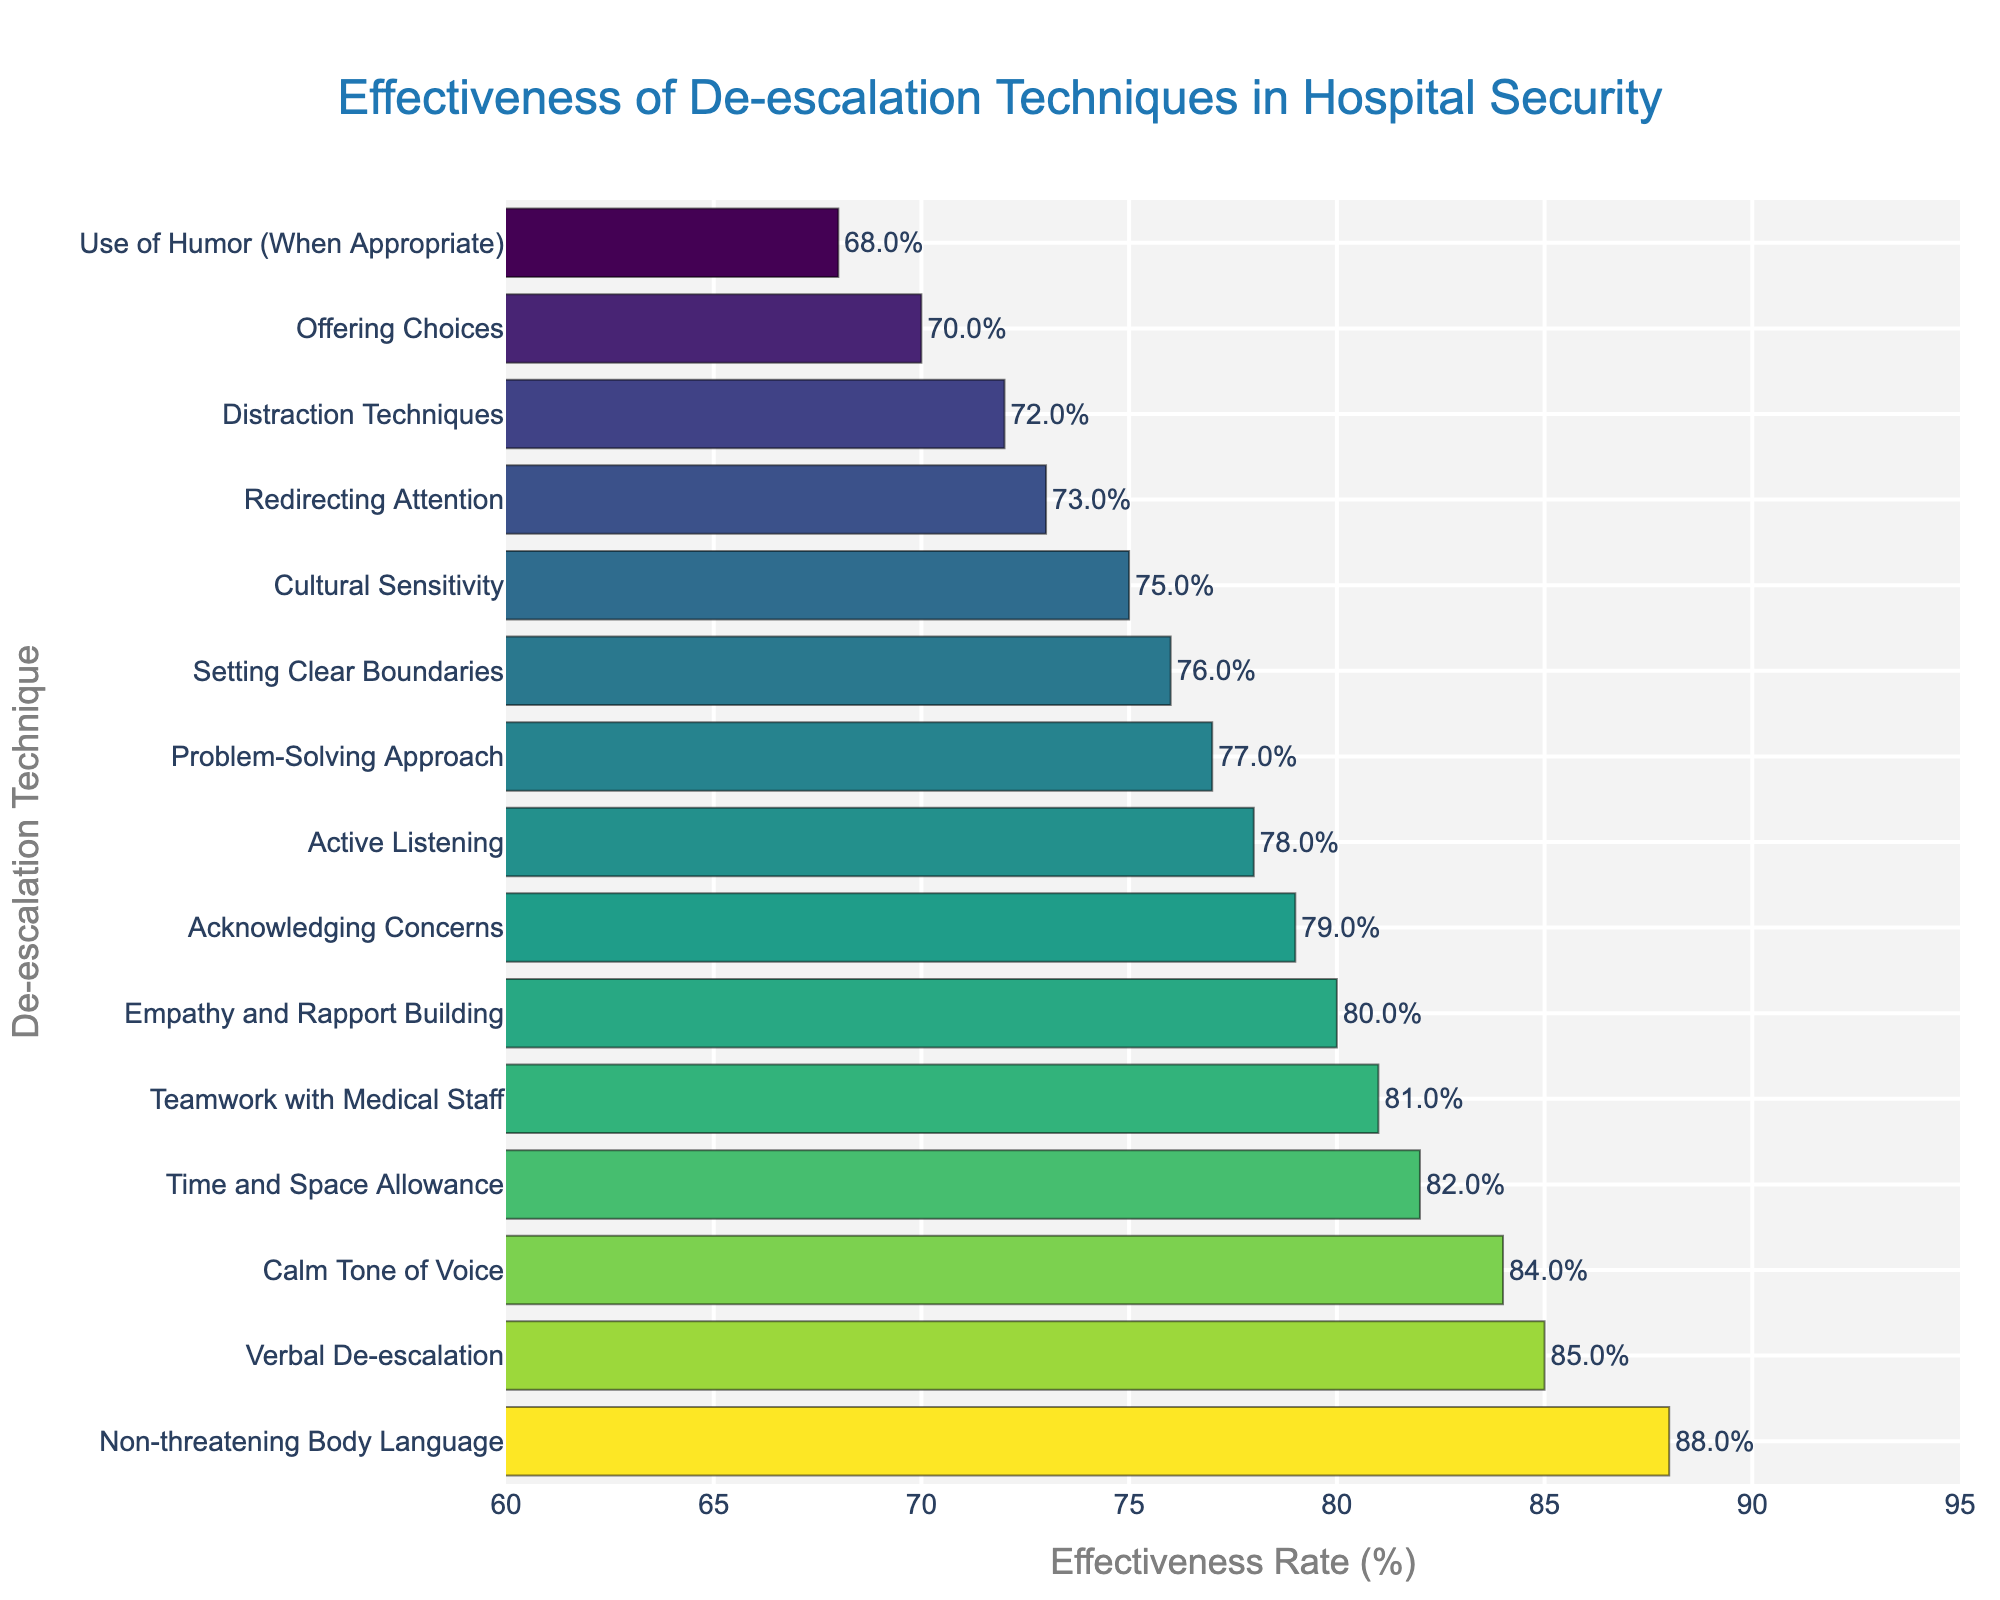What's the most effective de-escalation technique used by security staff? By observing the bars in the chart, the technique with the longest bar and highest effectiveness rate is the most effective.
Answer: Non-threatening Body Language Which technique has the lowest effectiveness rate? The technique with the shortest bar and lowest value is the least effective.
Answer: Use of Humor (When Appropriate) What is the combined effectiveness rate of 'Verbal De-escalation' and 'Calm Tone of Voice'? Summing the effectiveness rates of 'Verbal De-escalation' (85) and 'Calm Tone of Voice' (84) gives 85 + 84.
Answer: 169 How does 'Empathy and Rapport Building' compare to 'Setting Clear Boundaries' in terms of effectiveness? Comparing their effectiveness rates, 'Empathy and Rapport Building' has a rate of 80, while 'Setting Clear Boundaries' has a rate of 76, making the former more effective by 4%.
Answer: Empathy and Rapport Building is more effective by 4% Which three techniques have effectiveness rates closest to 80%? By closely examining the values, the techniques near 80% are 'Empathy and Rapport Building' (80%), 'Time and Space Allowance' (82%), and 'Acknowledging Concerns' (79%).
Answer: Empathy and Rapport Building, Time and Space Allowance, Acknowledging Concerns What is the average effectiveness rate of all the techniques? Summing all the effectiveness rates and dividing by the number of techniques, there are 15 techniques with a total effectiveness rate of 1188, hence the average is 1188/15.
Answer: 79.2% Which technique is more effective: 'Active Listening' or 'Problem-Solving Approach'? By comparing their effectiveness rates, 'Active Listening' has a rate of 78%, while 'Problem-Solving Approach' has a rate of 77%.
Answer: Active Listening What is the effectiveness rate range between the most and least effective techniques? The range is calculated by subtracting the rate of the least effective technique (68 for Use of Humor) from the most effective technique (88 for Non-threatening Body Language).
Answer: 20% How similar in effectiveness are 'Distraction Techniques' and 'Redirecting Attention'? Both techniques have close effectiveness rates, with 'Distraction Techniques' at 72% and 'Redirecting Attention' at 73%, differing by only 1%.
Answer: Differ by 1% What is the total effectiveness rate of all techniques employed? Adding all effectiveness rates together: 85 + 78 + 72 + 80 + 76 + 70 + 82 + 88 + 84 + 79 + 73 + 77 + 75 + 68 + 81 equals 1188.
Answer: 1188 